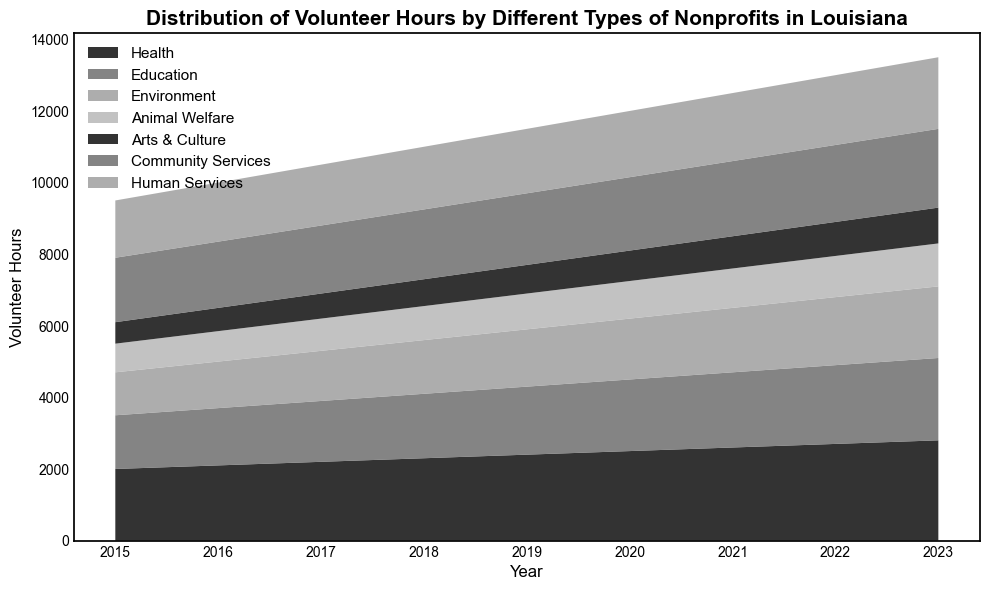What has been the trend in volunteer hours for the Health sector from 2015 to 2023? To find the trend, observe the line for the Health sector from 2015 to 2023. It starts at 2000 hours in 2015 and increases incrementally each year, reaching 2800 hours in 2023.
Answer: Increasing In which year did Community Services exceed 2000 volunteer hours? Look at the Community Services area. It passes over the 2000-hour mark in 2023.
Answer: 2023 Which sector had the smallest increase in volunteer hours between 2015 and 2023? Calculate the difference between the 2023 and 2015 values for each sector. The smallest increase is in Arts & Culture (1000 - 600 = 400).
Answer: Arts & Culture Did any sector's volunteer hours decrease from one year to the next? Scan the chart from left to right for each sector. No sector's volunteer hours decreased; they either stayed the same or increased each year.
Answer: No How do the 2023 volunteer hours for Environment compare to those for Arts & Culture? In 2023, Environment has 2000 hours, while Arts & Culture has 1000 hours.
Answer: Environment is greater What was the total number of volunteer hours across all sectors in 2020? Sum the 2020 values: 2500 (Health) + 2000 (Education) + 1700 (Environment) + 1050 (Animal Welfare) + 850 (Arts & Culture) + 2050 (Community Services) + 1850 (Human Services) = 12000.
Answer: 12000 Which sector showed the highest growth rate in volunteer hours between 2015 and 2023? Calculate the growth rate for each sector [(2023 value - 2015 value) / 2015 value]. The highest growth rate is for Animal Welfare [(1200 - 800) / 800 = 0.5].
Answer: Animal Welfare In which year did Education sector's volunteer hours first exceed 2000? Look at the Education sector's area. It surpasses 2000 hours in 2022.
Answer: 2022 Compare the size of the area representing Health volunteers to that representing Human Services in 2021. Which is larger? At 2021, the Health area (2600) is larger than the Human Services area (1900).
Answer: Health is larger What was the average volunteer hours for Community Services over the entire period (2015-2023)? Calculate the average: (1800 + 1850 + 1900 + 1950 + 2000 + 2050 + 2100 + 2150 + 2200) / 9 = 2000.
Answer: 2000 